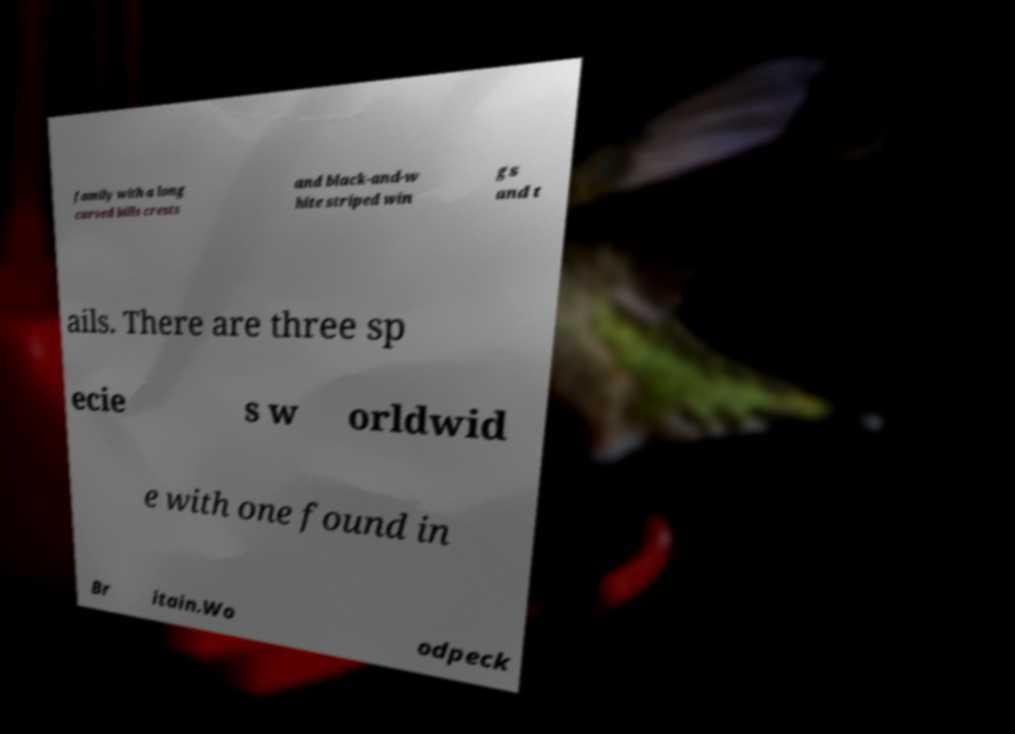What messages or text are displayed in this image? I need them in a readable, typed format. family with a long curved bills crests and black-and-w hite striped win gs and t ails. There are three sp ecie s w orldwid e with one found in Br itain.Wo odpeck 